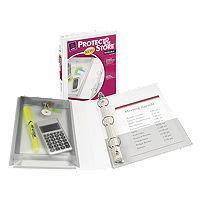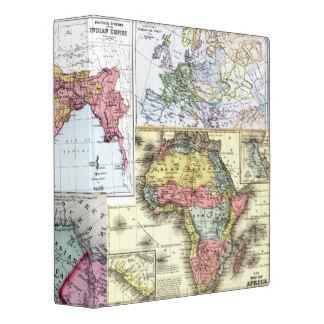The first image is the image on the left, the second image is the image on the right. Evaluate the accuracy of this statement regarding the images: "One of the binders has an interior pocket containing a calculator.". Is it true? Answer yes or no. Yes. The first image is the image on the left, the second image is the image on the right. Evaluate the accuracy of this statement regarding the images: "One of the binders itself, not the pages within, has maps as a design, on the visible part of the binder.". Is it true? Answer yes or no. Yes. 